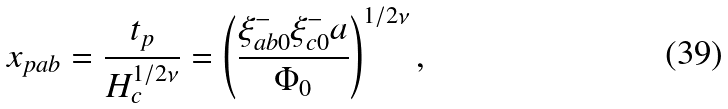<formula> <loc_0><loc_0><loc_500><loc_500>x _ { p a b } = \frac { t _ { p } } { H _ { c } ^ { 1 / 2 \nu } } = \left ( \frac { \xi _ { a b 0 } ^ { - } \xi _ { c 0 } ^ { - } a } { \Phi _ { 0 } } \right ) ^ { 1 / 2 \nu } ,</formula> 